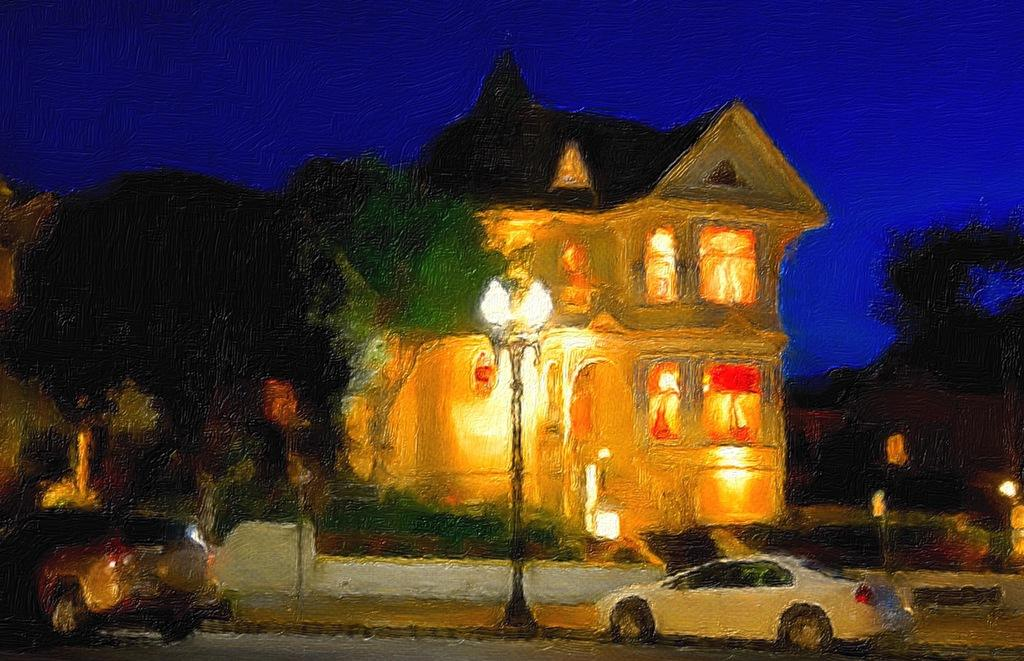What is the main subject of the painting? The painting depicts two vehicles. What is attached to the pole in the painting? There is a pole with lights in the painting. What type of vegetation can be seen behind the pole? There are trees visible behind the pole. What is visible in the background of the painting? There is a building and the sky visible in the background of the painting. What type of treatment is being administered to the word in the painting? There is no word present in the painting, so no treatment can be administered. 